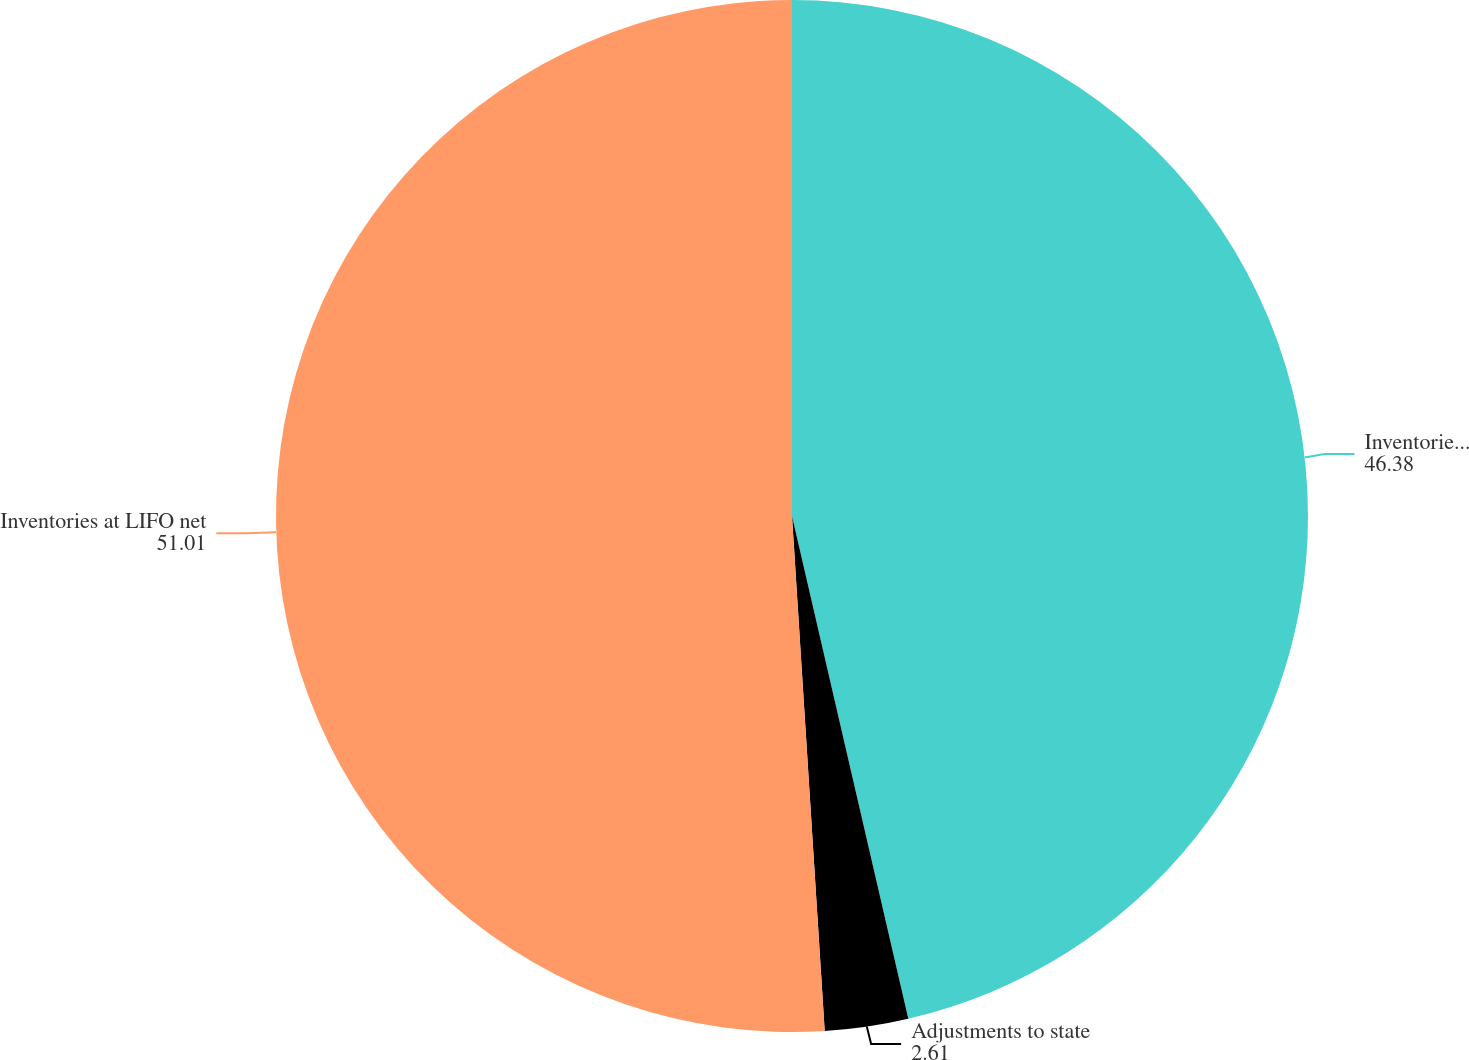<chart> <loc_0><loc_0><loc_500><loc_500><pie_chart><fcel>Inventories at FIFO net<fcel>Adjustments to state<fcel>Inventories at LIFO net<nl><fcel>46.38%<fcel>2.61%<fcel>51.01%<nl></chart> 